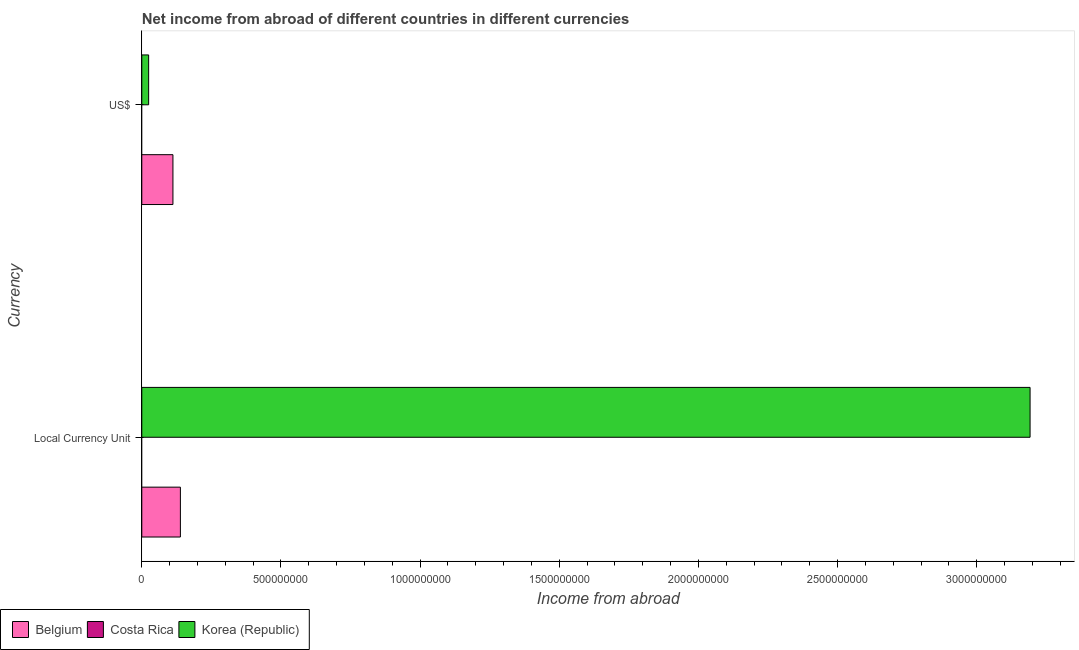How many different coloured bars are there?
Ensure brevity in your answer.  2. How many groups of bars are there?
Keep it short and to the point. 2. Are the number of bars per tick equal to the number of legend labels?
Your answer should be compact. No. Are the number of bars on each tick of the Y-axis equal?
Make the answer very short. Yes. How many bars are there on the 1st tick from the top?
Ensure brevity in your answer.  2. What is the label of the 2nd group of bars from the top?
Your answer should be very brief. Local Currency Unit. What is the income from abroad in constant 2005 us$ in Belgium?
Provide a succinct answer. 1.39e+08. Across all countries, what is the maximum income from abroad in constant 2005 us$?
Make the answer very short. 3.19e+09. Across all countries, what is the minimum income from abroad in us$?
Make the answer very short. 0. What is the total income from abroad in us$ in the graph?
Provide a succinct answer. 1.36e+08. What is the difference between the income from abroad in us$ in Korea (Republic) and that in Belgium?
Make the answer very short. -8.73e+07. What is the difference between the income from abroad in constant 2005 us$ in Costa Rica and the income from abroad in us$ in Belgium?
Your answer should be compact. -1.12e+08. What is the average income from abroad in constant 2005 us$ per country?
Offer a terse response. 1.11e+09. What is the difference between the income from abroad in us$ and income from abroad in constant 2005 us$ in Belgium?
Your answer should be very brief. -2.68e+07. What is the ratio of the income from abroad in us$ in Belgium to that in Korea (Republic)?
Offer a very short reply. 4.56. Is the income from abroad in us$ in Belgium less than that in Korea (Republic)?
Make the answer very short. No. In how many countries, is the income from abroad in constant 2005 us$ greater than the average income from abroad in constant 2005 us$ taken over all countries?
Your answer should be compact. 1. What is the difference between two consecutive major ticks on the X-axis?
Keep it short and to the point. 5.00e+08. Are the values on the major ticks of X-axis written in scientific E-notation?
Make the answer very short. No. What is the title of the graph?
Make the answer very short. Net income from abroad of different countries in different currencies. Does "OECD members" appear as one of the legend labels in the graph?
Offer a very short reply. No. What is the label or title of the X-axis?
Your answer should be very brief. Income from abroad. What is the label or title of the Y-axis?
Your answer should be compact. Currency. What is the Income from abroad of Belgium in Local Currency Unit?
Offer a terse response. 1.39e+08. What is the Income from abroad of Korea (Republic) in Local Currency Unit?
Your response must be concise. 3.19e+09. What is the Income from abroad in Belgium in US$?
Offer a terse response. 1.12e+08. What is the Income from abroad in Costa Rica in US$?
Provide a succinct answer. 0. What is the Income from abroad in Korea (Republic) in US$?
Your response must be concise. 2.45e+07. Across all Currency, what is the maximum Income from abroad of Belgium?
Ensure brevity in your answer.  1.39e+08. Across all Currency, what is the maximum Income from abroad in Korea (Republic)?
Provide a succinct answer. 3.19e+09. Across all Currency, what is the minimum Income from abroad in Belgium?
Give a very brief answer. 1.12e+08. Across all Currency, what is the minimum Income from abroad in Korea (Republic)?
Your answer should be very brief. 2.45e+07. What is the total Income from abroad of Belgium in the graph?
Your response must be concise. 2.50e+08. What is the total Income from abroad of Korea (Republic) in the graph?
Provide a short and direct response. 3.22e+09. What is the difference between the Income from abroad of Belgium in Local Currency Unit and that in US$?
Offer a terse response. 2.68e+07. What is the difference between the Income from abroad of Korea (Republic) in Local Currency Unit and that in US$?
Keep it short and to the point. 3.17e+09. What is the difference between the Income from abroad of Belgium in Local Currency Unit and the Income from abroad of Korea (Republic) in US$?
Ensure brevity in your answer.  1.14e+08. What is the average Income from abroad of Belgium per Currency?
Keep it short and to the point. 1.25e+08. What is the average Income from abroad of Costa Rica per Currency?
Ensure brevity in your answer.  0. What is the average Income from abroad in Korea (Republic) per Currency?
Your answer should be compact. 1.61e+09. What is the difference between the Income from abroad of Belgium and Income from abroad of Korea (Republic) in Local Currency Unit?
Provide a succinct answer. -3.05e+09. What is the difference between the Income from abroad in Belgium and Income from abroad in Korea (Republic) in US$?
Your answer should be very brief. 8.73e+07. What is the ratio of the Income from abroad of Belgium in Local Currency Unit to that in US$?
Offer a terse response. 1.24. What is the ratio of the Income from abroad in Korea (Republic) in Local Currency Unit to that in US$?
Your answer should be very brief. 130. What is the difference between the highest and the second highest Income from abroad in Belgium?
Make the answer very short. 2.68e+07. What is the difference between the highest and the second highest Income from abroad of Korea (Republic)?
Your response must be concise. 3.17e+09. What is the difference between the highest and the lowest Income from abroad of Belgium?
Your response must be concise. 2.68e+07. What is the difference between the highest and the lowest Income from abroad in Korea (Republic)?
Keep it short and to the point. 3.17e+09. 